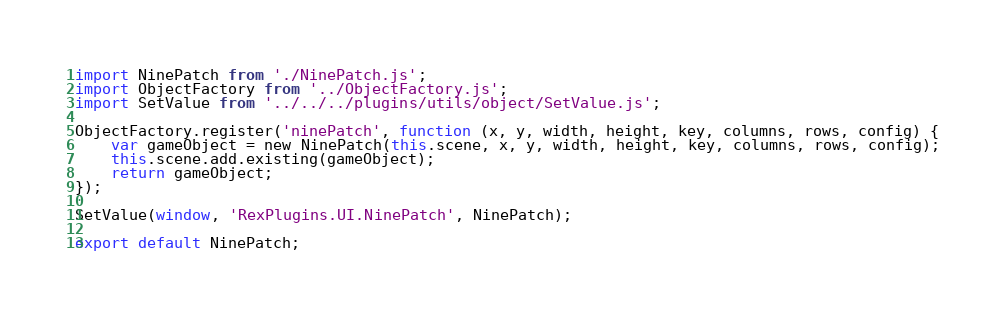Convert code to text. <code><loc_0><loc_0><loc_500><loc_500><_JavaScript_>import NinePatch from './NinePatch.js';
import ObjectFactory from '../ObjectFactory.js';
import SetValue from '../../../plugins/utils/object/SetValue.js';

ObjectFactory.register('ninePatch', function (x, y, width, height, key, columns, rows, config) {
    var gameObject = new NinePatch(this.scene, x, y, width, height, key, columns, rows, config);
    this.scene.add.existing(gameObject);
    return gameObject;
});

SetValue(window, 'RexPlugins.UI.NinePatch', NinePatch);

export default NinePatch;</code> 